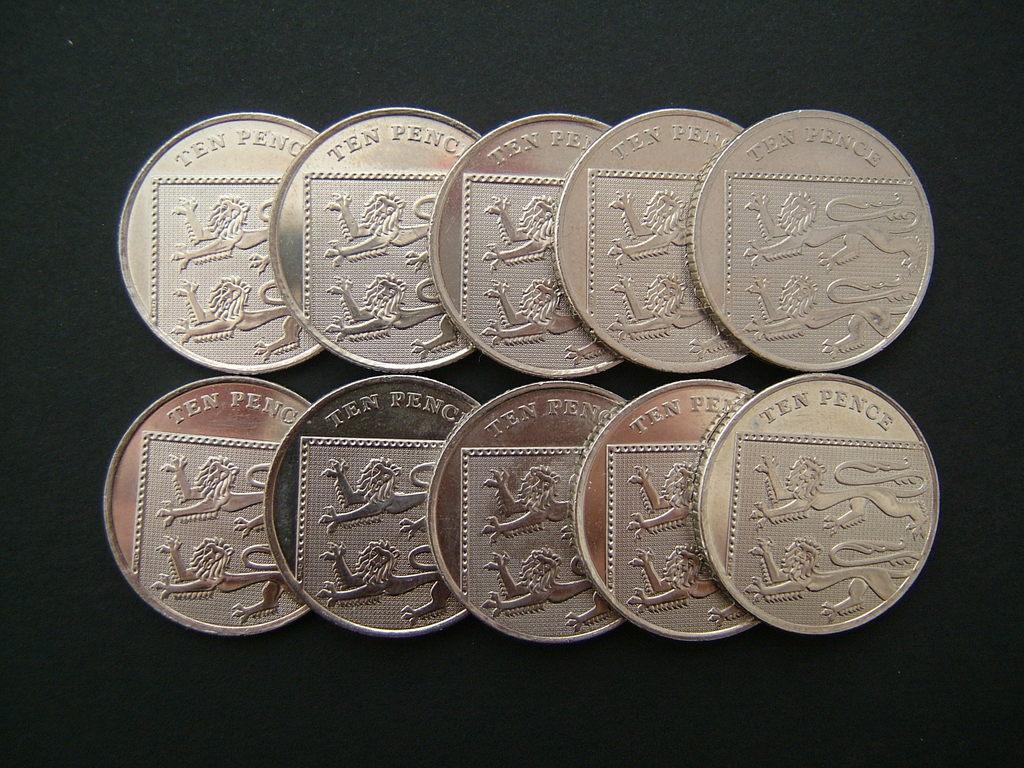How many pence is each coin?
Provide a short and direct response. Ten. How many pence are all these coins combined?
Offer a terse response. 100. 